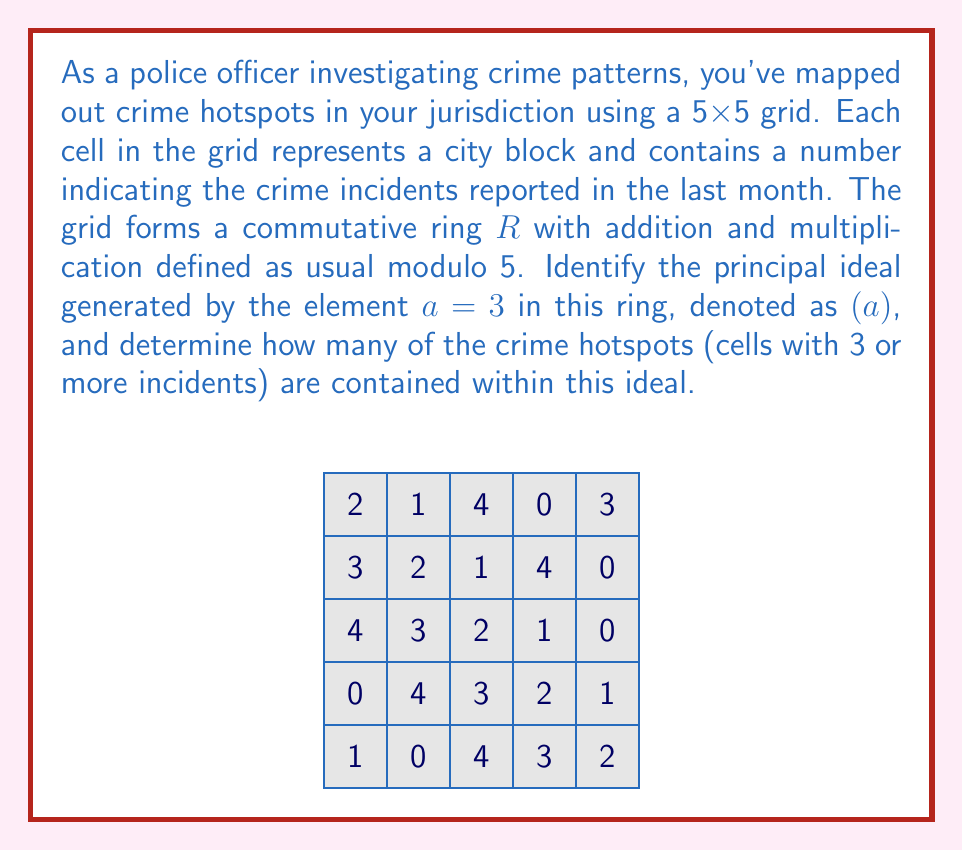Teach me how to tackle this problem. Let's approach this step-by-step:

1) In a commutative ring, the principal ideal generated by an element $a$ is defined as:

   $(a) = \{ra \mid r \in R\}$

2) In our case, $a = 3$ and operations are modulo 5. So we need to calculate:

   $3 \cdot 0 \equiv 0 \pmod{5}$
   $3 \cdot 1 \equiv 3 \pmod{5}$
   $3 \cdot 2 \equiv 1 \pmod{5}$
   $3 \cdot 3 \equiv 4 \pmod{5}$
   $3 \cdot 4 \equiv 2 \pmod{5}$

3) Therefore, the principal ideal $(3)$ in this ring is $\{0, 1, 2, 3, 4\}$, which is the entire ring.

4) Now, we need to count the number of cells in the grid with values 3 or more (crime hotspots) that are in this ideal.

5) Since the ideal includes all elements of the ring, all crime hotspots are contained within it.

6) Counting the cells with values 3 or more in the grid:
   - There are 5 cells with value 3
   - There are 5 cells with value 4

7) In total, there are 10 crime hotspots in the grid.
Answer: 10 